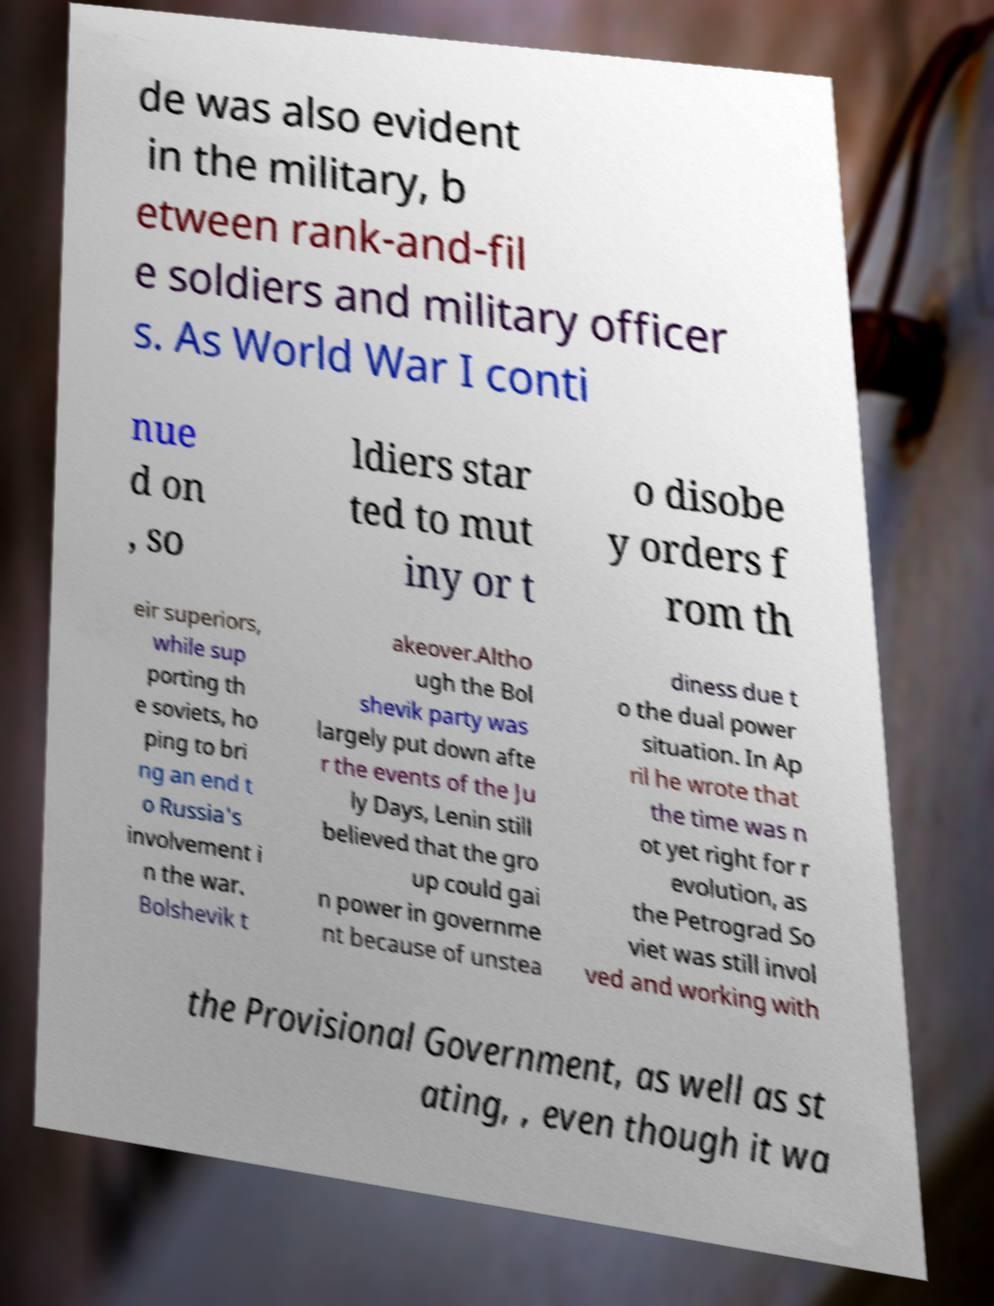Please read and relay the text visible in this image. What does it say? de was also evident in the military, b etween rank-and-fil e soldiers and military officer s. As World War I conti nue d on , so ldiers star ted to mut iny or t o disobe y orders f rom th eir superiors, while sup porting th e soviets, ho ping to bri ng an end t o Russia's involvement i n the war. Bolshevik t akeover.Altho ugh the Bol shevik party was largely put down afte r the events of the Ju ly Days, Lenin still believed that the gro up could gai n power in governme nt because of unstea diness due t o the dual power situation. In Ap ril he wrote that the time was n ot yet right for r evolution, as the Petrograd So viet was still invol ved and working with the Provisional Government, as well as st ating, , even though it wa 